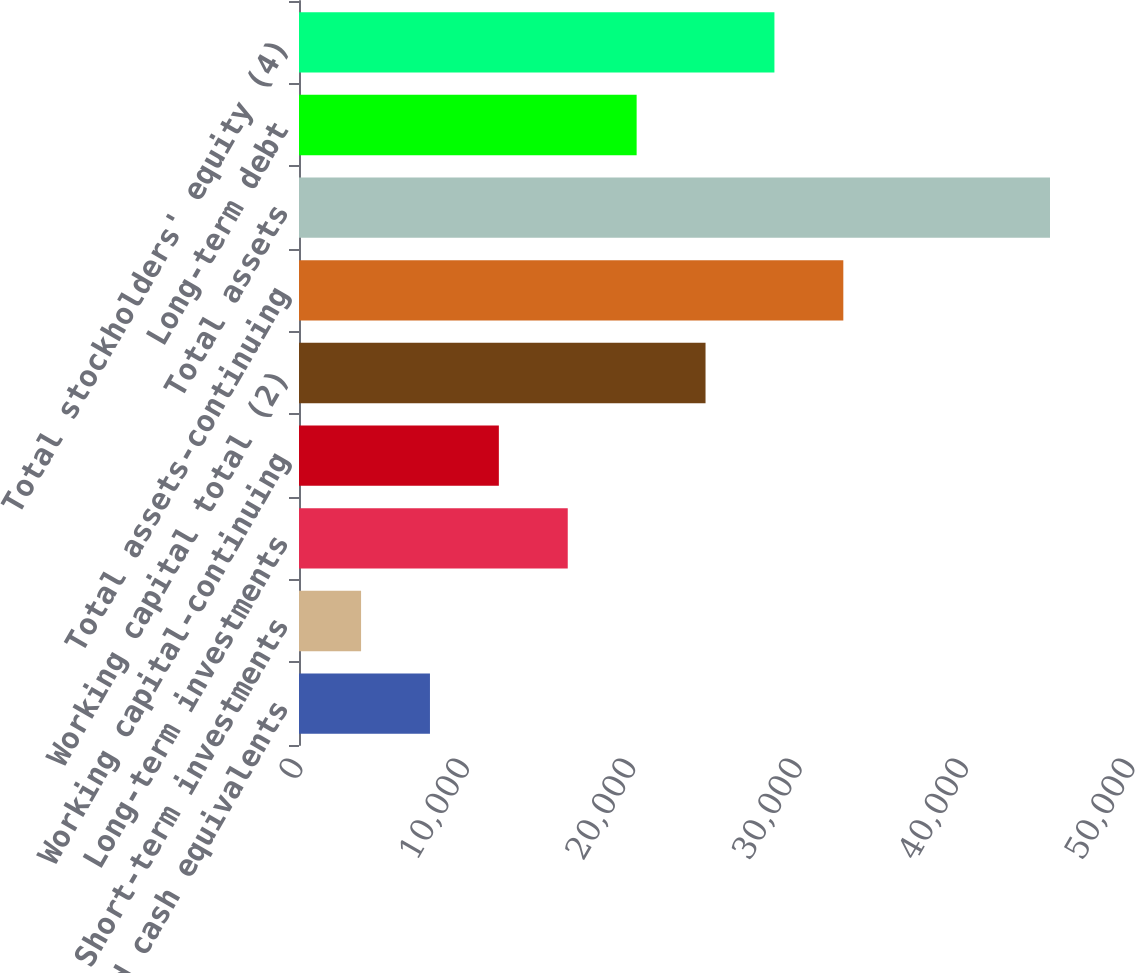<chart> <loc_0><loc_0><loc_500><loc_500><bar_chart><fcel>Cash and cash equivalents<fcel>Short-term investments<fcel>Long-term investments<fcel>Working capital-continuing<fcel>Working capital total (2)<fcel>Total assets-continuing<fcel>Total assets<fcel>Long-term debt<fcel>Total stockholders' equity (4)<nl><fcel>7870.2<fcel>3730<fcel>16150.6<fcel>12010.4<fcel>24431<fcel>32711.4<fcel>45132<fcel>20290.8<fcel>28571.2<nl></chart> 